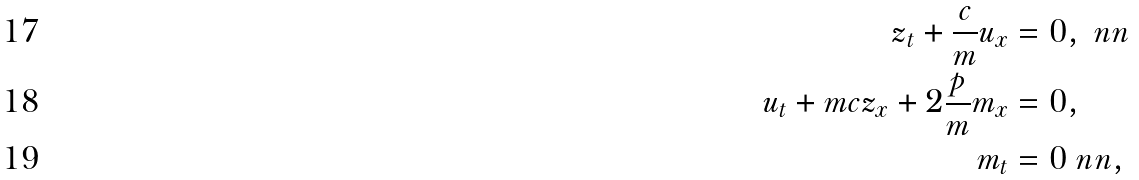<formula> <loc_0><loc_0><loc_500><loc_500>z _ { t } + \frac { c } { m } u _ { x } & = 0 , \ n n \\ u _ { t } + m c z _ { x } + 2 \frac { p } { m } m _ { x } & = 0 , \\ m _ { t } & = 0 \ n n ,</formula> 